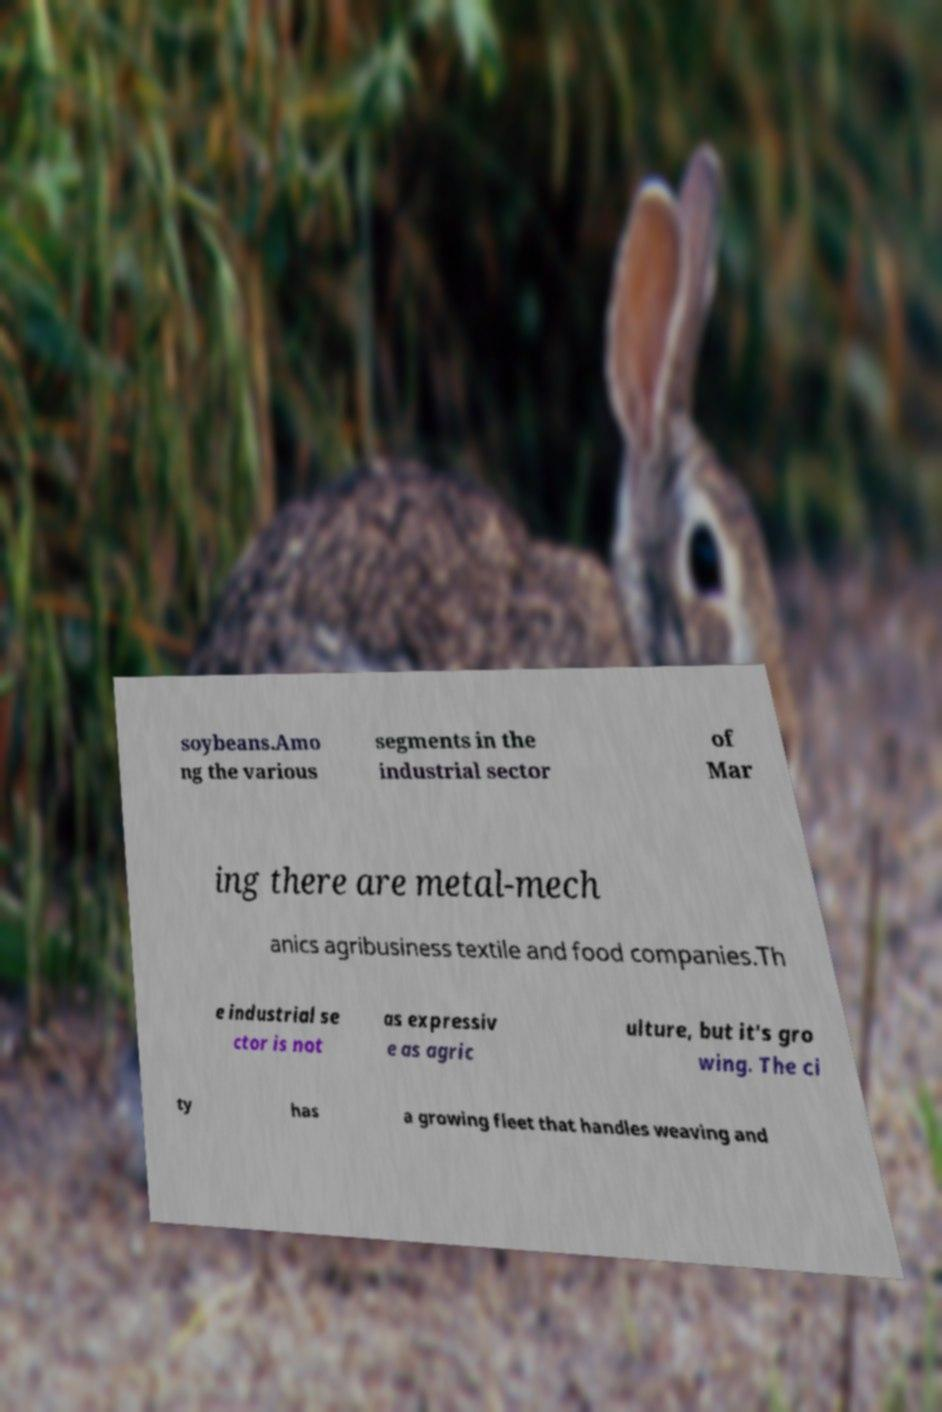There's text embedded in this image that I need extracted. Can you transcribe it verbatim? soybeans.Amo ng the various segments in the industrial sector of Mar ing there are metal-mech anics agribusiness textile and food companies.Th e industrial se ctor is not as expressiv e as agric ulture, but it's gro wing. The ci ty has a growing fleet that handles weaving and 